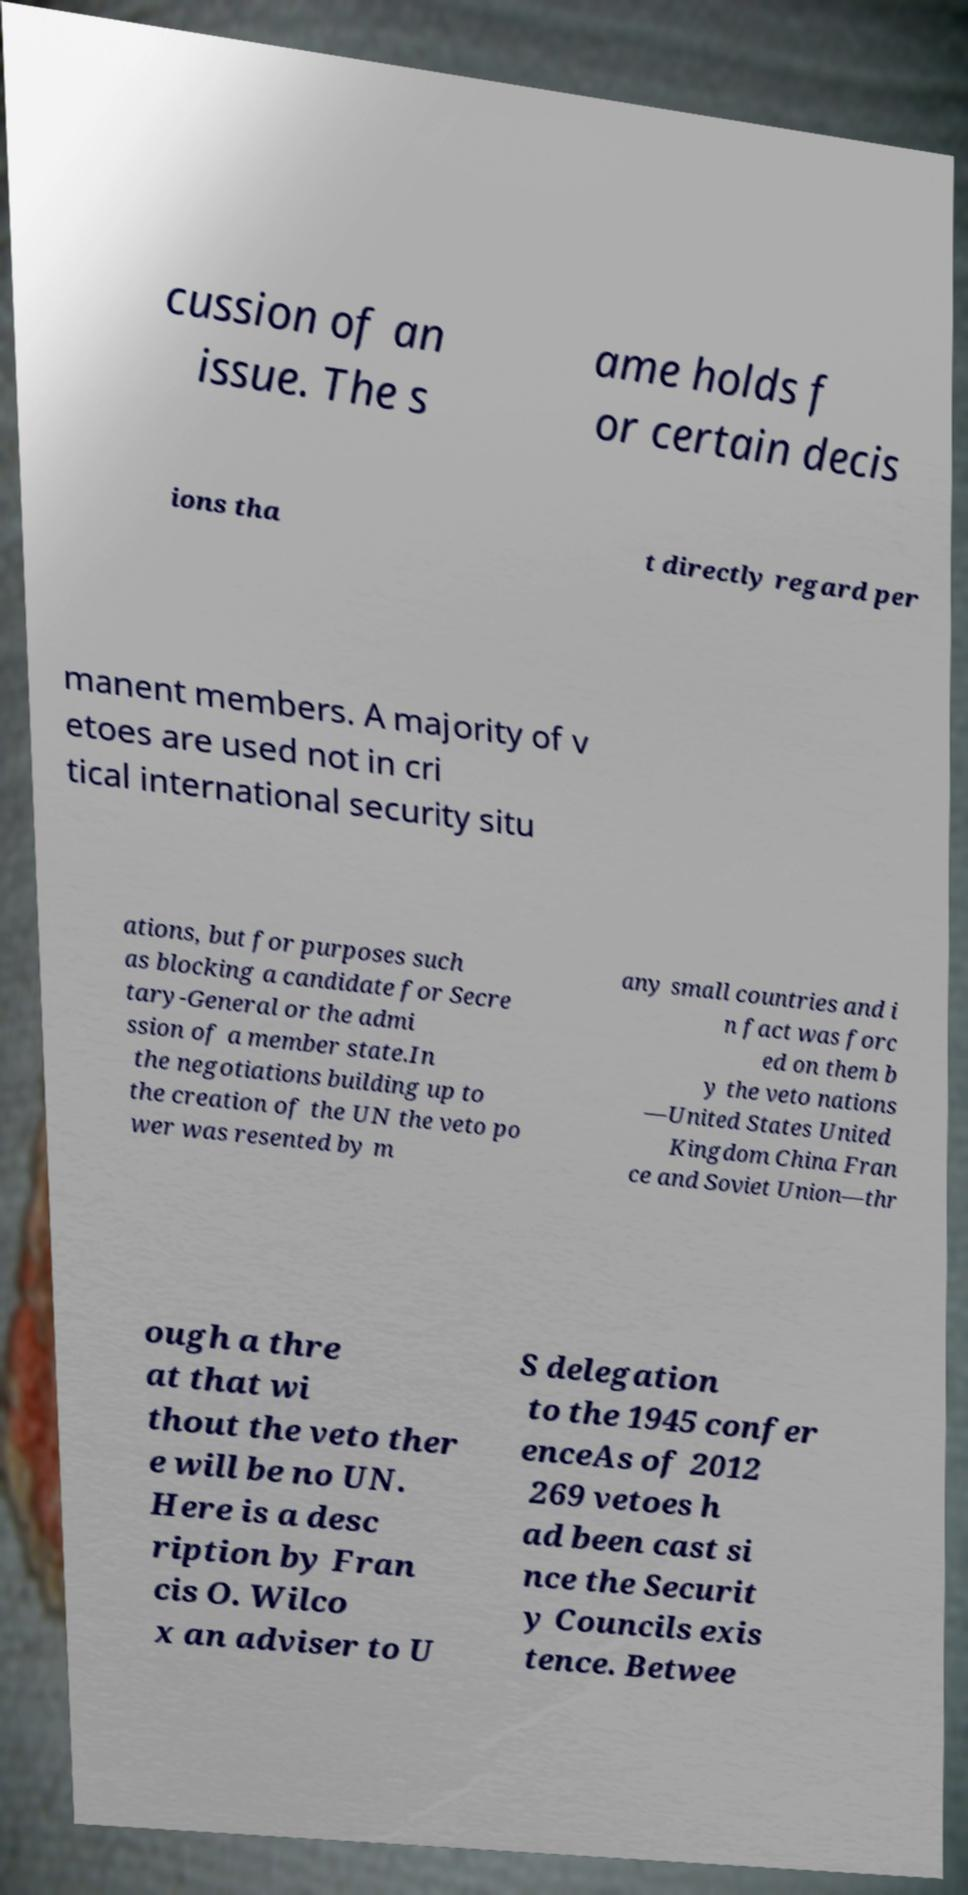There's text embedded in this image that I need extracted. Can you transcribe it verbatim? cussion of an issue. The s ame holds f or certain decis ions tha t directly regard per manent members. A majority of v etoes are used not in cri tical international security situ ations, but for purposes such as blocking a candidate for Secre tary-General or the admi ssion of a member state.In the negotiations building up to the creation of the UN the veto po wer was resented by m any small countries and i n fact was forc ed on them b y the veto nations —United States United Kingdom China Fran ce and Soviet Union—thr ough a thre at that wi thout the veto ther e will be no UN. Here is a desc ription by Fran cis O. Wilco x an adviser to U S delegation to the 1945 confer enceAs of 2012 269 vetoes h ad been cast si nce the Securit y Councils exis tence. Betwee 